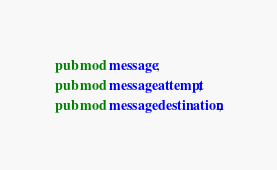<code> <loc_0><loc_0><loc_500><loc_500><_Rust_>pub mod message;
pub mod messageattempt;
pub mod messagedestination;
</code> 